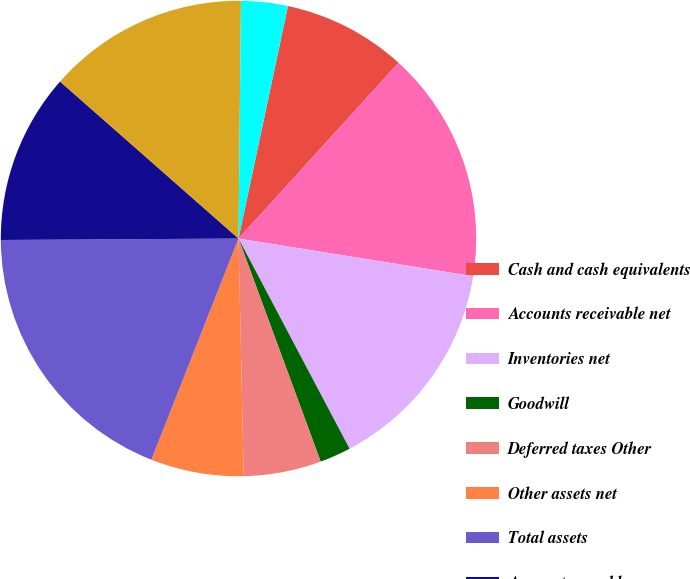Convert chart to OTSL. <chart><loc_0><loc_0><loc_500><loc_500><pie_chart><fcel>Cash and cash equivalents<fcel>Accounts receivable net<fcel>Inventories net<fcel>Goodwill<fcel>Deferred taxes Other<fcel>Other assets net<fcel>Total assets<fcel>Accounts payable<fcel>Accrued liabilities<fcel>Debt due within one year<nl><fcel>8.42%<fcel>15.78%<fcel>14.73%<fcel>2.12%<fcel>5.27%<fcel>6.32%<fcel>18.93%<fcel>11.58%<fcel>13.68%<fcel>3.17%<nl></chart> 